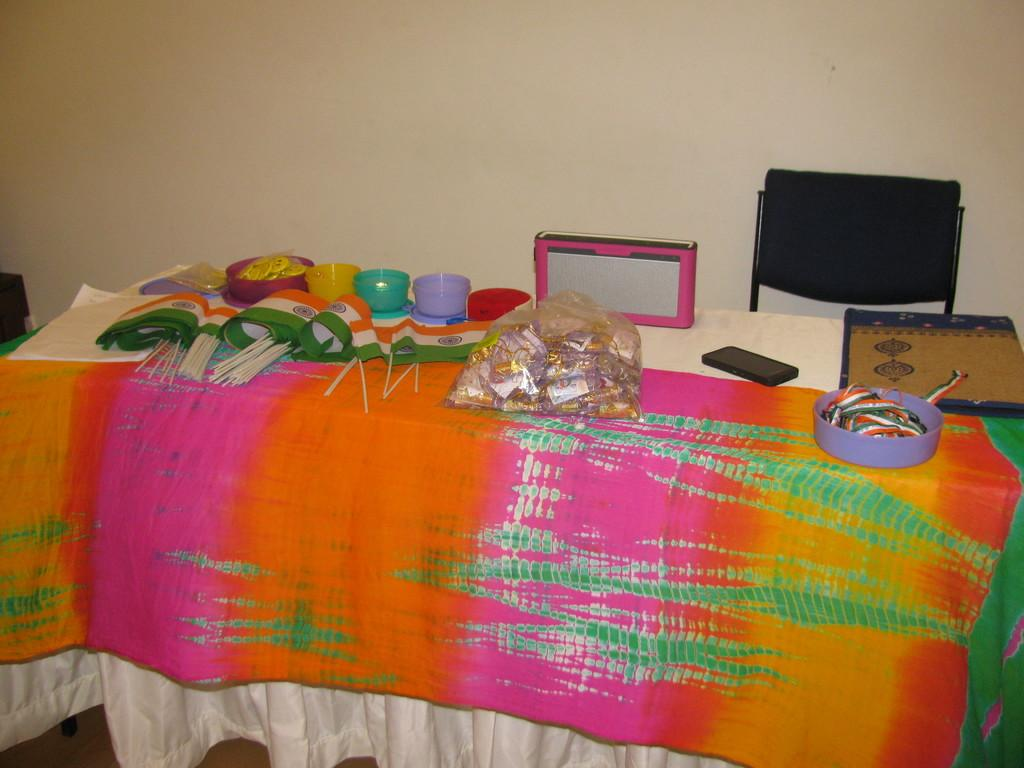What can be seen in the image that represents a symbol or country? There are flags in the image. What objects are present that might be used for holding or serving food? There are bowls in the image. What is covering the items on the table in the image? There is a plastic cover in the image. What else is present on the table in the image? There are other unspecified things on the table. What piece of furniture is located beside the table in the image? There is a chair beside the table in the image. What book is causing anger in the image? There is no book or indication of anger present in the image. What type of carriage is visible in the image? There is no carriage present in the image. 